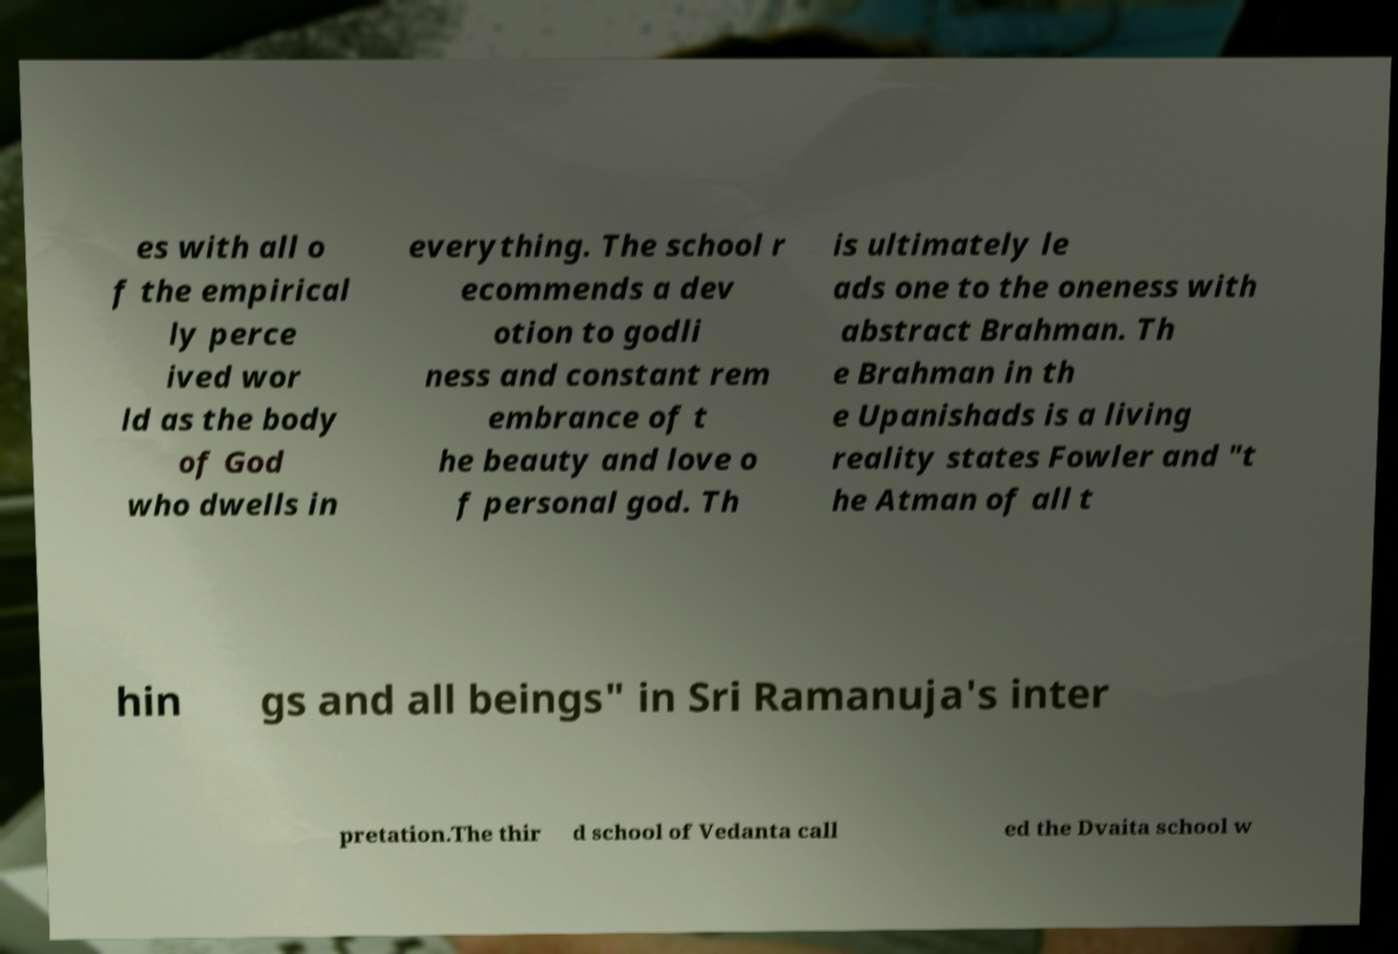What messages or text are displayed in this image? I need them in a readable, typed format. es with all o f the empirical ly perce ived wor ld as the body of God who dwells in everything. The school r ecommends a dev otion to godli ness and constant rem embrance of t he beauty and love o f personal god. Th is ultimately le ads one to the oneness with abstract Brahman. Th e Brahman in th e Upanishads is a living reality states Fowler and "t he Atman of all t hin gs and all beings" in Sri Ramanuja's inter pretation.The thir d school of Vedanta call ed the Dvaita school w 